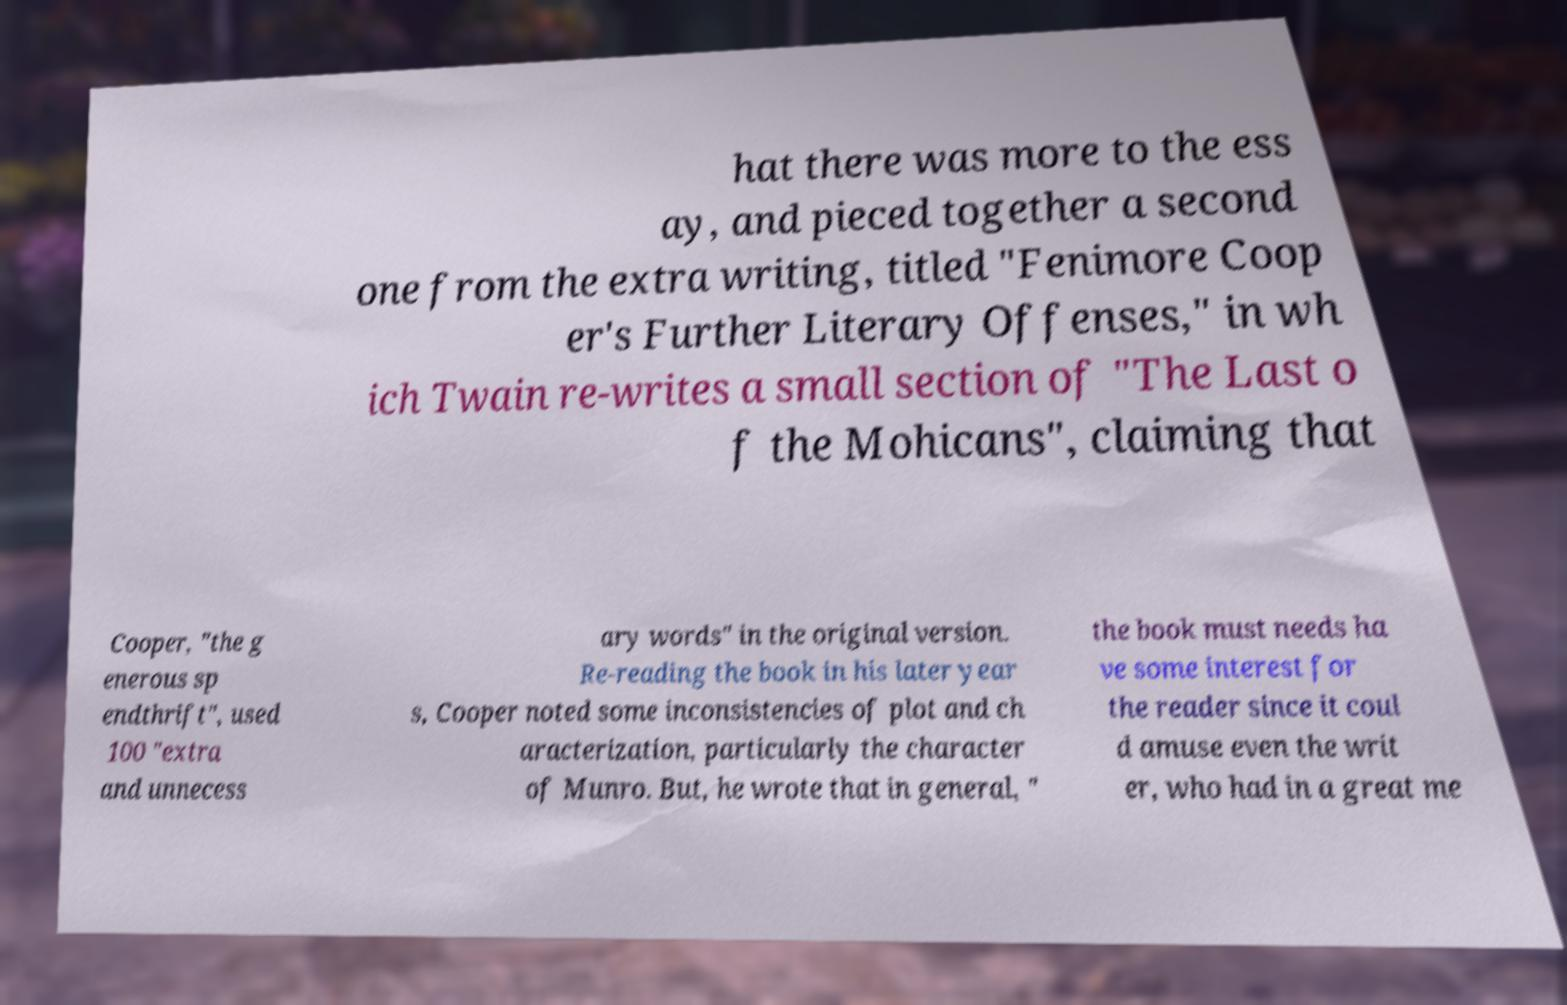Could you assist in decoding the text presented in this image and type it out clearly? hat there was more to the ess ay, and pieced together a second one from the extra writing, titled "Fenimore Coop er's Further Literary Offenses," in wh ich Twain re-writes a small section of "The Last o f the Mohicans", claiming that Cooper, "the g enerous sp endthrift", used 100 "extra and unnecess ary words" in the original version. Re-reading the book in his later year s, Cooper noted some inconsistencies of plot and ch aracterization, particularly the character of Munro. But, he wrote that in general, " the book must needs ha ve some interest for the reader since it coul d amuse even the writ er, who had in a great me 